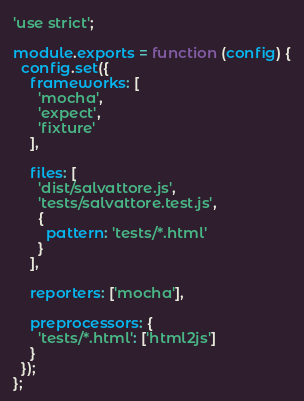<code> <loc_0><loc_0><loc_500><loc_500><_JavaScript_>'use strict';

module.exports = function (config) {
  config.set({
    frameworks: [
      'mocha',
      'expect',
      'fixture'
    ],

    files: [
      'dist/salvattore.js',
      'tests/salvattore.test.js',
      {
        pattern: 'tests/*.html'
      }
    ],

    reporters: ['mocha'],

    preprocessors: {
      'tests/*.html': ['html2js']
    }
  });
};
</code> 